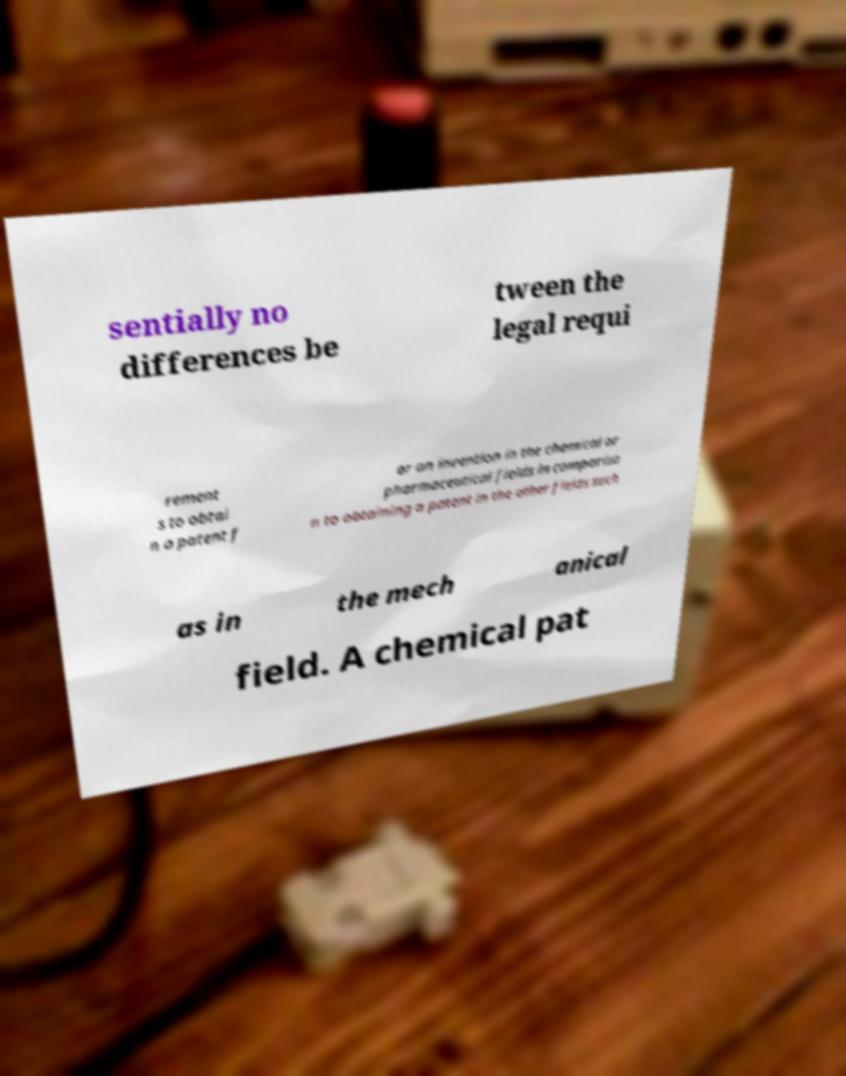Could you assist in decoding the text presented in this image and type it out clearly? sentially no differences be tween the legal requi rement s to obtai n a patent f or an invention in the chemical or pharmaceutical fields in compariso n to obtaining a patent in the other fields such as in the mech anical field. A chemical pat 